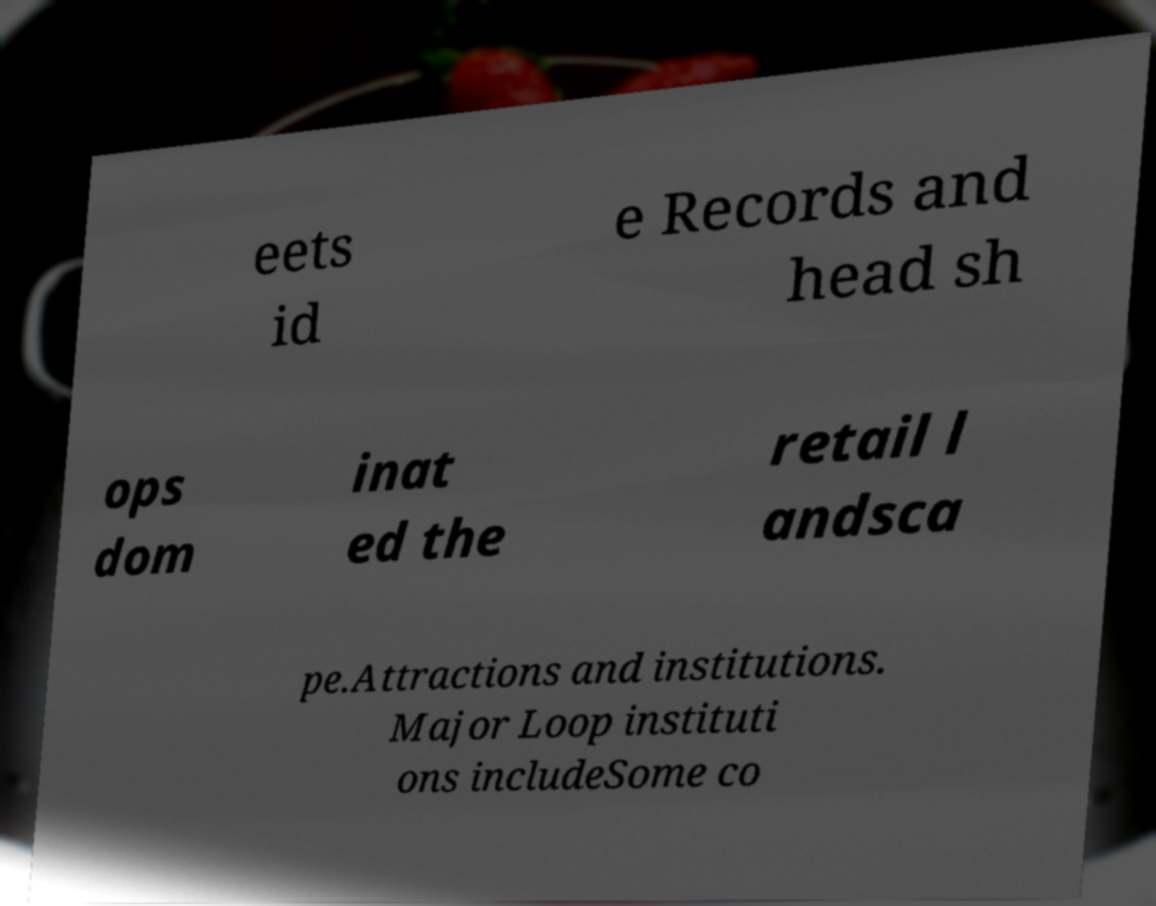Can you accurately transcribe the text from the provided image for me? eets id e Records and head sh ops dom inat ed the retail l andsca pe.Attractions and institutions. Major Loop instituti ons includeSome co 